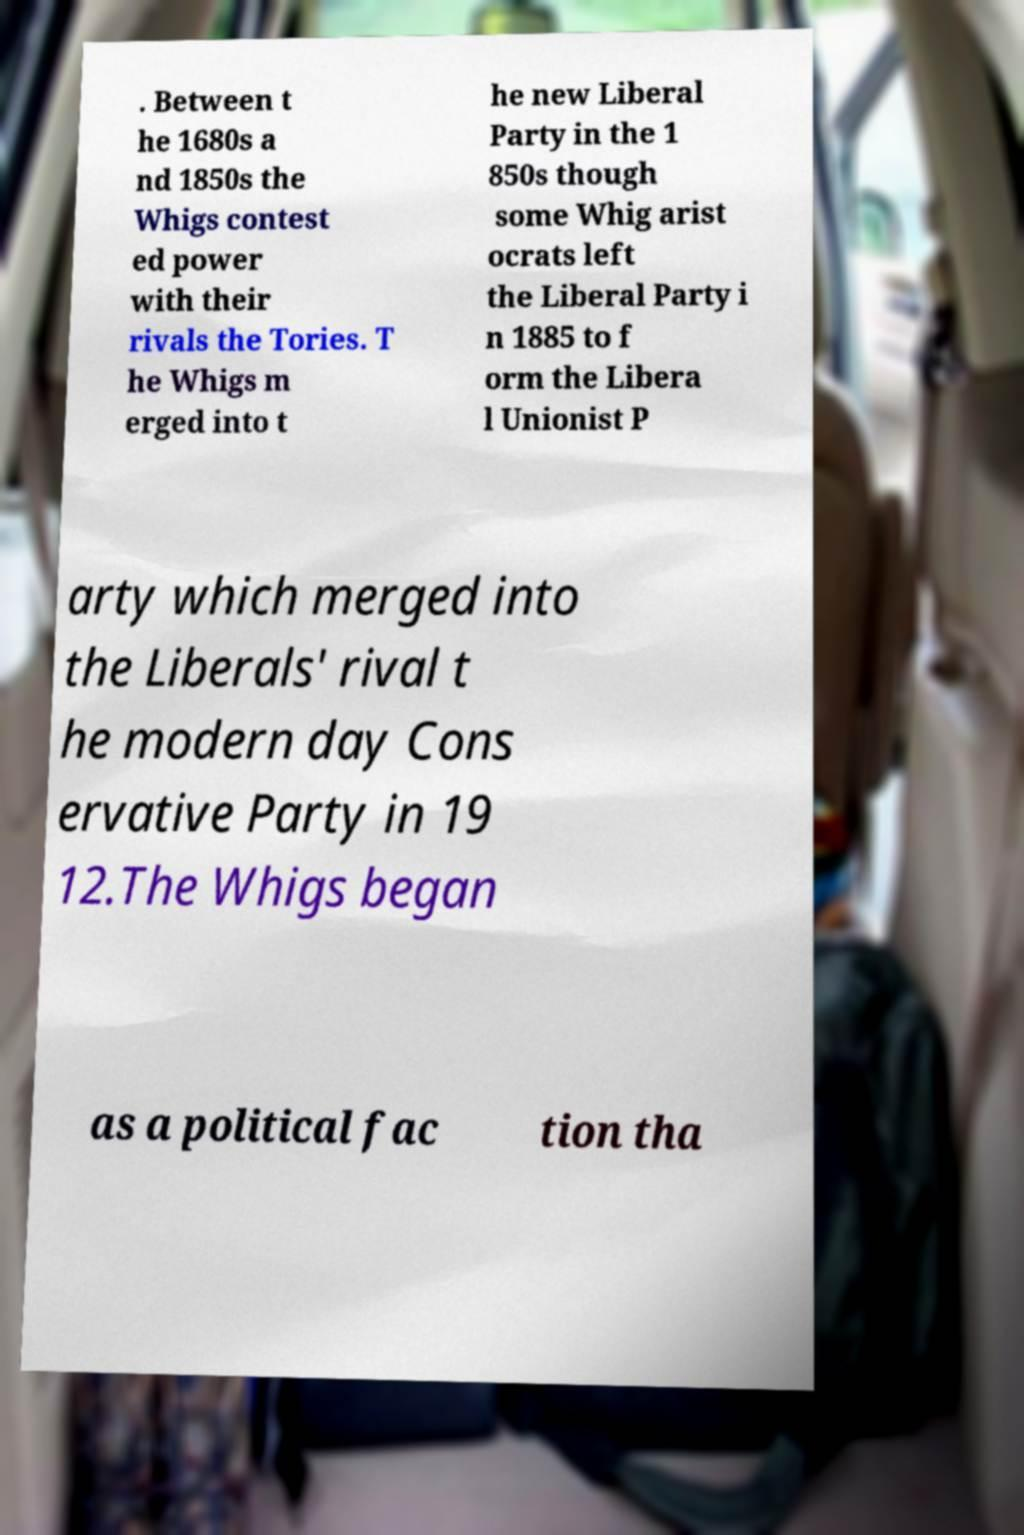I need the written content from this picture converted into text. Can you do that? . Between t he 1680s a nd 1850s the Whigs contest ed power with their rivals the Tories. T he Whigs m erged into t he new Liberal Party in the 1 850s though some Whig arist ocrats left the Liberal Party i n 1885 to f orm the Libera l Unionist P arty which merged into the Liberals' rival t he modern day Cons ervative Party in 19 12.The Whigs began as a political fac tion tha 